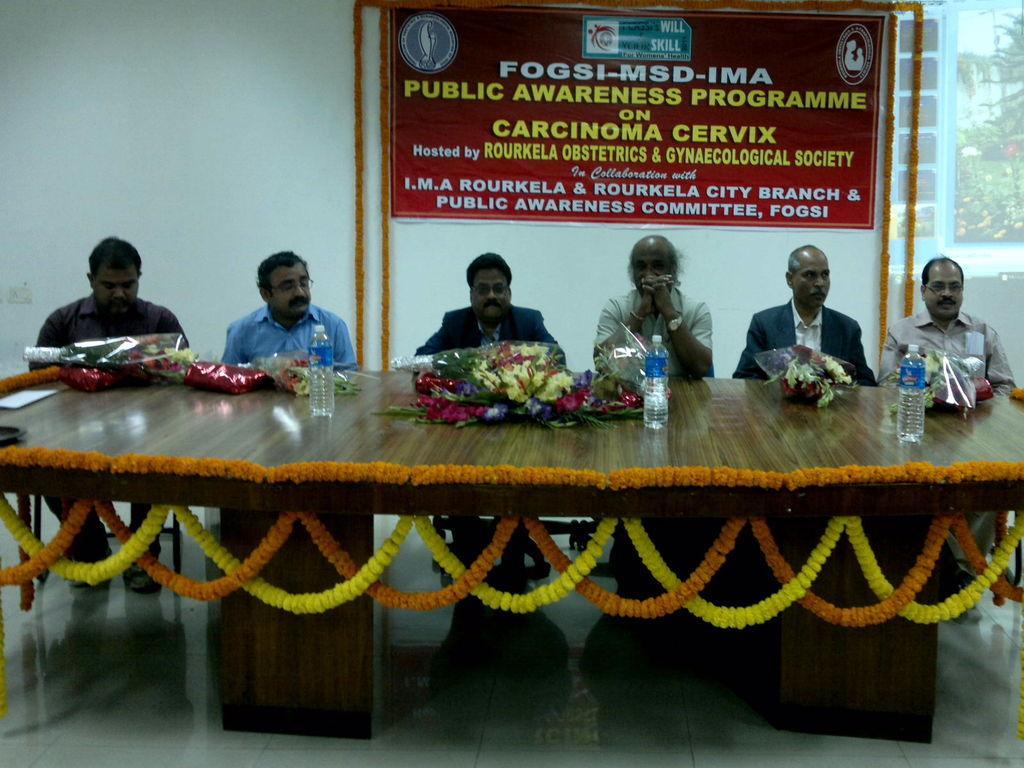Can you describe this image briefly? This image is clicked inside. There are six persons sitting in this image, sitting in the chairs near the table. The table is decorated with flowers. On the table there are bottles. In the background, there is a wall on which a banner is fixed. 